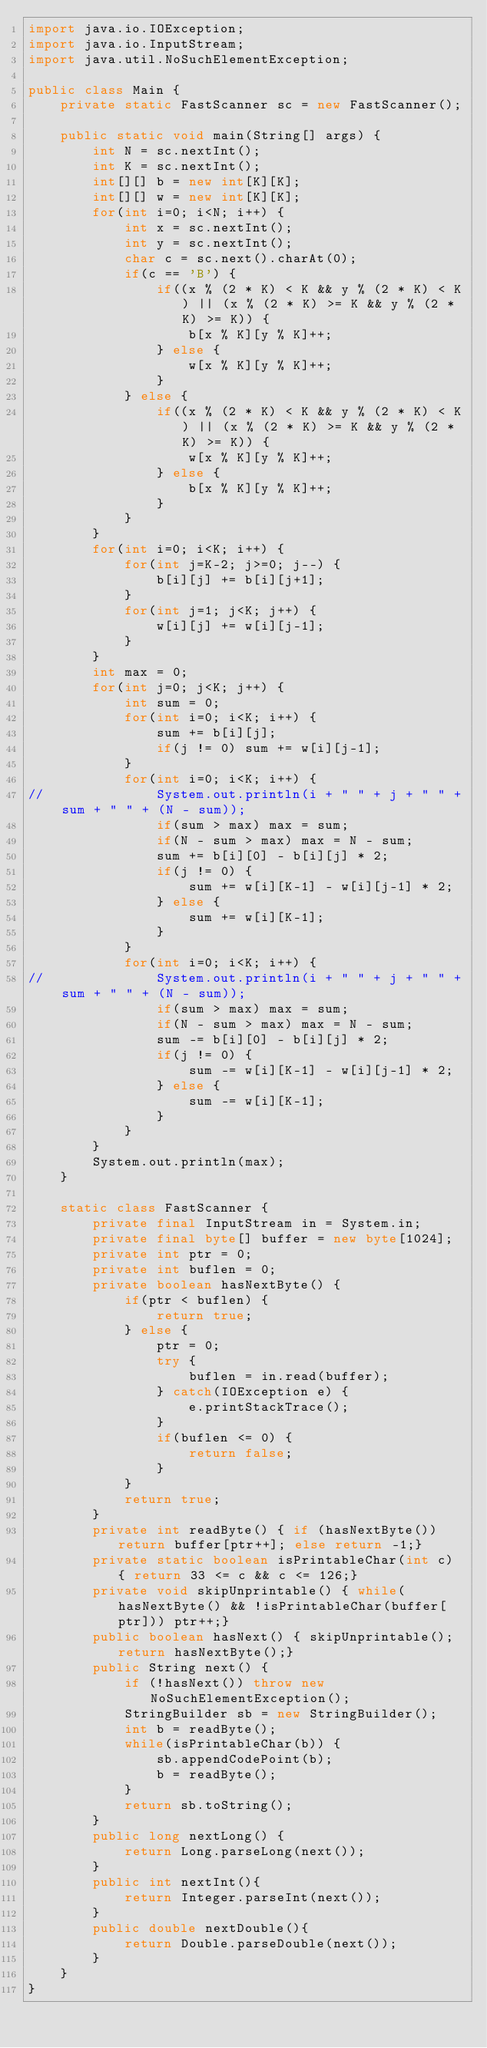<code> <loc_0><loc_0><loc_500><loc_500><_Java_>import java.io.IOException;
import java.io.InputStream;
import java.util.NoSuchElementException;
 
public class Main {
	private static FastScanner sc = new FastScanner();
	
	public static void main(String[] args) {
		int N = sc.nextInt();
		int K = sc.nextInt();
		int[][] b = new int[K][K];
		int[][] w = new int[K][K];
		for(int i=0; i<N; i++) {
			int x = sc.nextInt();
			int y = sc.nextInt();
			char c = sc.next().charAt(0);
			if(c == 'B') {
				if((x % (2 * K) < K && y % (2 * K) < K) || (x % (2 * K) >= K && y % (2 * K) >= K)) {
					b[x % K][y % K]++;
				} else {
					w[x % K][y % K]++;
				}
			} else {
				if((x % (2 * K) < K && y % (2 * K) < K) || (x % (2 * K) >= K && y % (2 * K) >= K)) {
					w[x % K][y % K]++;
				} else {
					b[x % K][y % K]++;
				}
			}
		}
		for(int i=0; i<K; i++) {
			for(int j=K-2; j>=0; j--) {
				b[i][j] += b[i][j+1];
			}
			for(int j=1; j<K; j++) {
				w[i][j] += w[i][j-1];
			}
		}
		int max = 0;
		for(int j=0; j<K; j++) {
			int sum = 0;
			for(int i=0; i<K; i++) {
				sum += b[i][j];
				if(j != 0) sum += w[i][j-1];
			}
			for(int i=0; i<K; i++) {
//				System.out.println(i + " " + j + " " + sum + " " + (N - sum));
				if(sum > max) max = sum;
				if(N - sum > max) max = N - sum;
				sum += b[i][0] - b[i][j] * 2;
				if(j != 0) {
					sum += w[i][K-1] - w[i][j-1] * 2;
				} else {
					sum += w[i][K-1];
				}
			}
			for(int i=0; i<K; i++) {
//				System.out.println(i + " " + j + " " + sum + " " + (N - sum));
				if(sum > max) max = sum;
				if(N - sum > max) max = N - sum;
				sum -= b[i][0] - b[i][j] * 2;
				if(j != 0) {
					sum -= w[i][K-1] - w[i][j-1] * 2;
				} else {
					sum -= w[i][K-1];
				}
			}
		}
		System.out.println(max);
	}
	
	static class FastScanner {
        private final InputStream in = System.in;
        private final byte[] buffer = new byte[1024];
        private int ptr = 0;
        private int buflen = 0;
        private boolean hasNextByte() {
            if(ptr < buflen) {
                return true;
            } else {
                ptr = 0;
                try {
                    buflen = in.read(buffer);
                } catch(IOException e) {
                    e.printStackTrace();
                }
                if(buflen <= 0) {
                    return false;
                }
            }
            return true;
        }
        private int readByte() { if (hasNextByte()) return buffer[ptr++]; else return -1;}
        private static boolean isPrintableChar(int c) { return 33 <= c && c <= 126;}
        private void skipUnprintable() { while(hasNextByte() && !isPrintableChar(buffer[ptr])) ptr++;}
        public boolean hasNext() { skipUnprintable(); return hasNextByte();}
        public String next() {
            if (!hasNext()) throw new NoSuchElementException();
            StringBuilder sb = new StringBuilder();
            int b = readByte();
            while(isPrintableChar(b)) {
                sb.appendCodePoint(b);
                b = readByte();
            }
            return sb.toString();
        }
        public long nextLong() {
            return Long.parseLong(next());
        }
        public int nextInt(){
            return Integer.parseInt(next());
        }
        public double nextDouble(){
            return Double.parseDouble(next());
        }
    }
}
</code> 